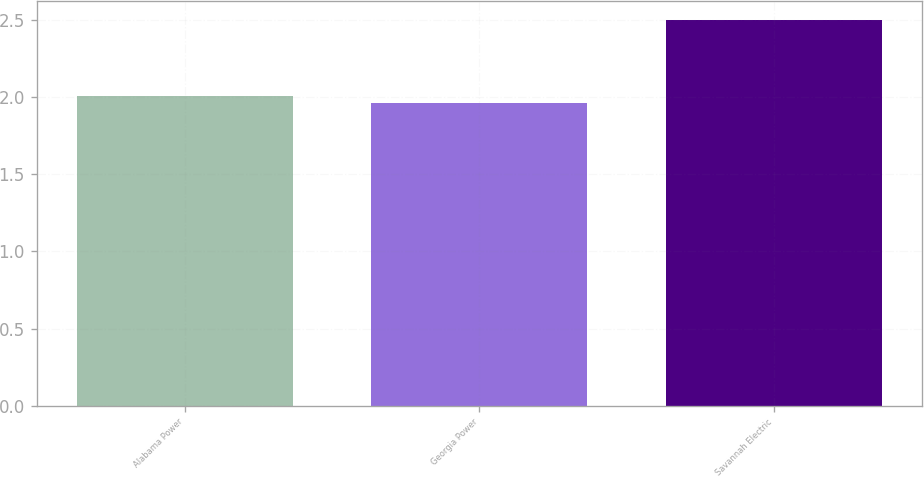Convert chart. <chart><loc_0><loc_0><loc_500><loc_500><bar_chart><fcel>Alabama Power<fcel>Georgia Power<fcel>Savannah Electric<nl><fcel>2.01<fcel>1.96<fcel>2.5<nl></chart> 